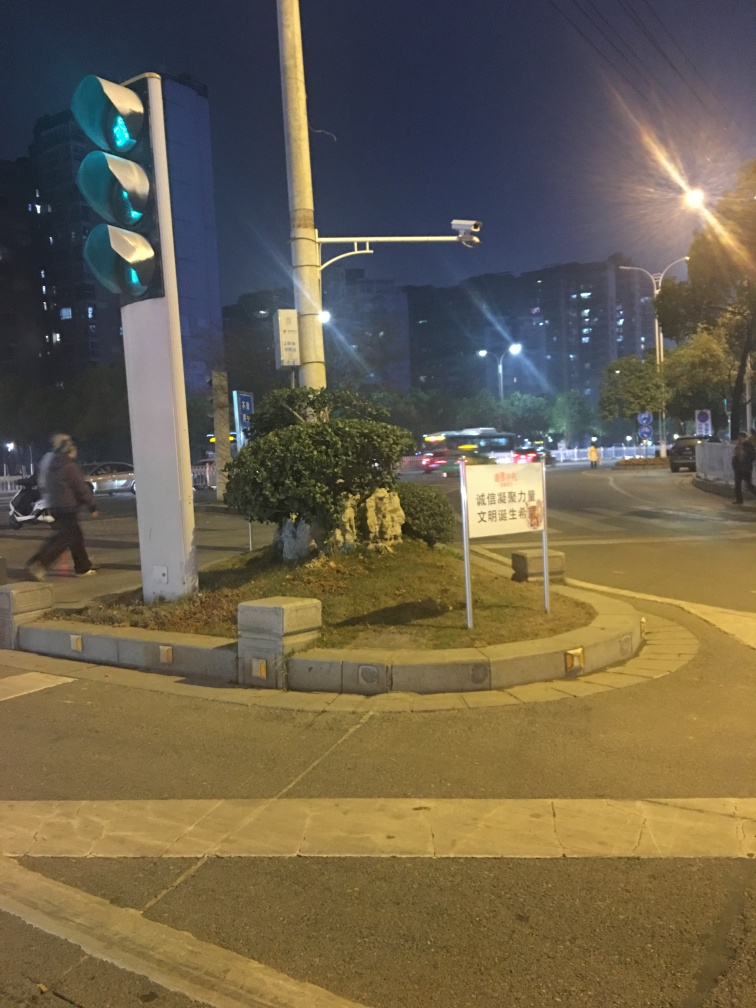What is the composition of the image?
A. rotated
B. slight tilt
C. upright
Answer with the option's letter from the given choices directly.
 B. 